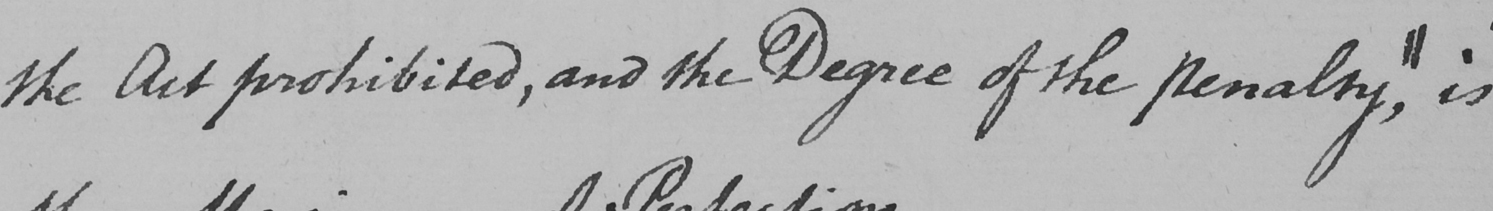What does this handwritten line say? the Act prohibited , and the Degree of the penalty , || is 